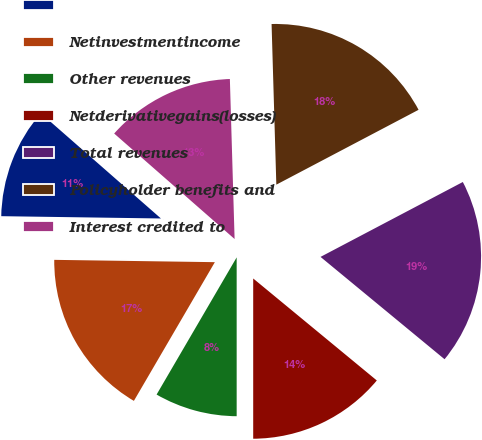Convert chart to OTSL. <chart><loc_0><loc_0><loc_500><loc_500><pie_chart><ecel><fcel>Netinvestmentincome<fcel>Other revenues<fcel>Netderivativegains(losses)<fcel>Total revenues<fcel>Policyholder benefits and<fcel>Interest credited to<nl><fcel>11.22%<fcel>16.82%<fcel>8.41%<fcel>14.02%<fcel>18.69%<fcel>17.76%<fcel>13.08%<nl></chart> 